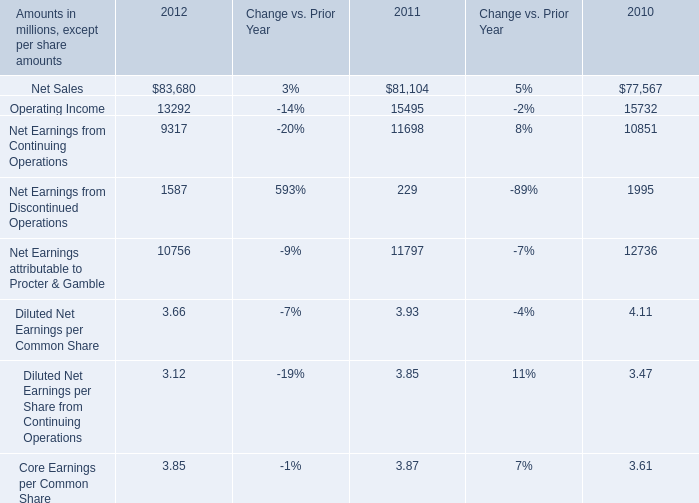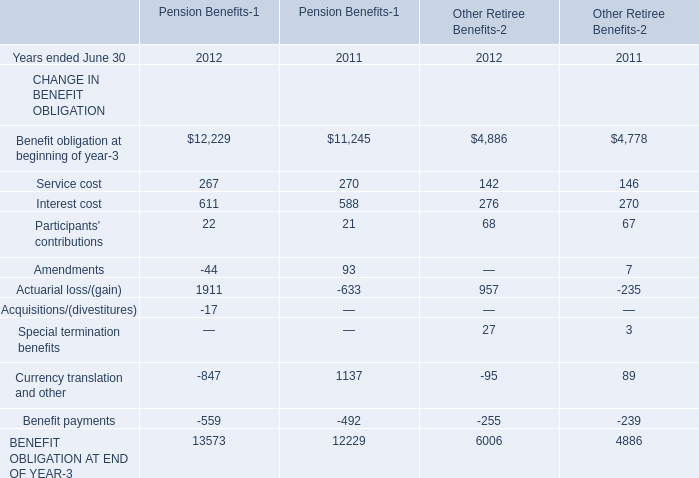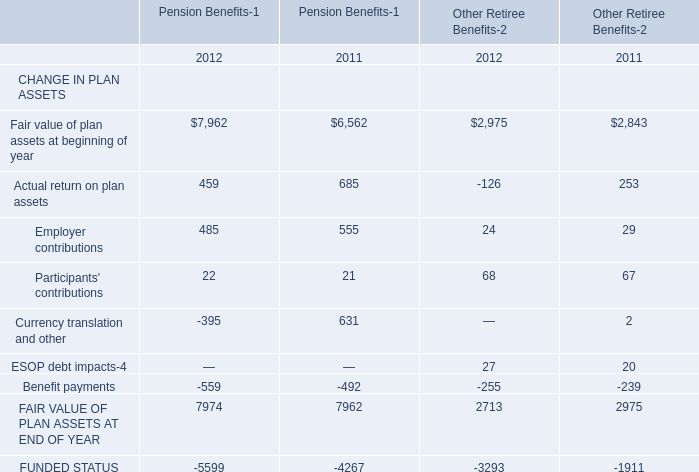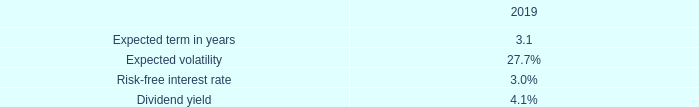What is the growing rate of Currency translation and other for Pension Benefits-1 in the year with the most Actual return on plan assets for Pension Benefits-1? 
Computations: ((-395 - 631) / 631)
Answer: -1.62599. 